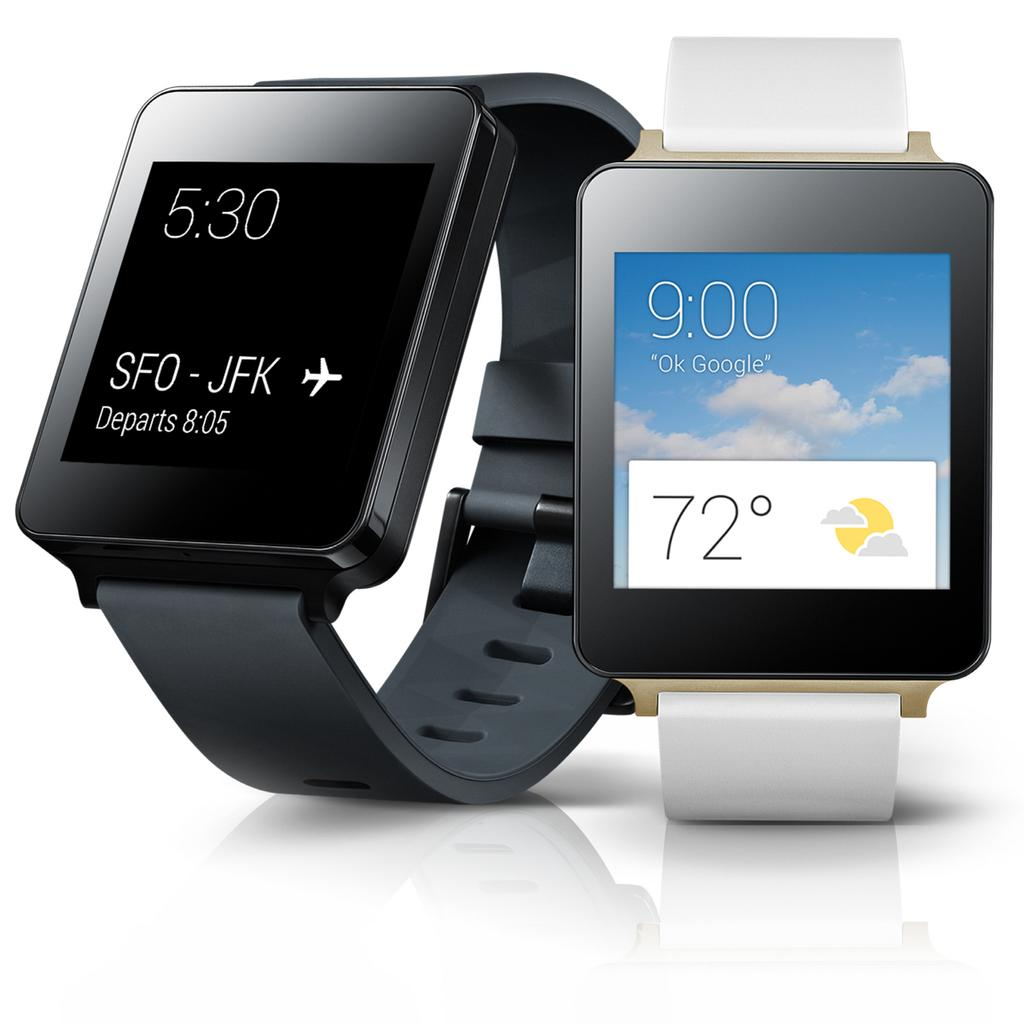How many digital watches are visible in the image? There are two digital watches in the image. What is the color of the surface on which the watches are placed? The image has a white surface. What type of sugar is being used to take a picture of the watches in the image? There is no sugar or camera present in the image; it only features two digital watches on a white surface. 